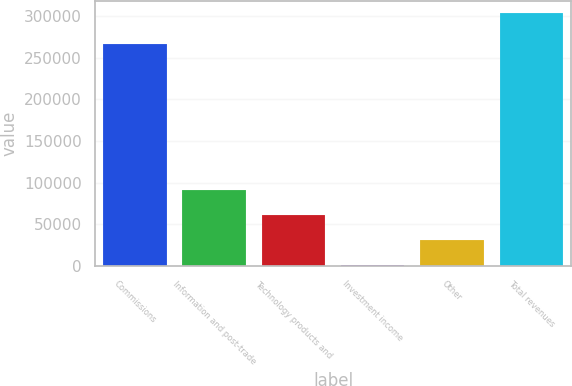Convert chart to OTSL. <chart><loc_0><loc_0><loc_500><loc_500><bar_chart><fcel>Commissions<fcel>Information and post-trade<fcel>Technology products and<fcel>Investment income<fcel>Other<fcel>Total revenues<nl><fcel>266221<fcel>91562.9<fcel>61343.6<fcel>905<fcel>31124.3<fcel>303098<nl></chart> 